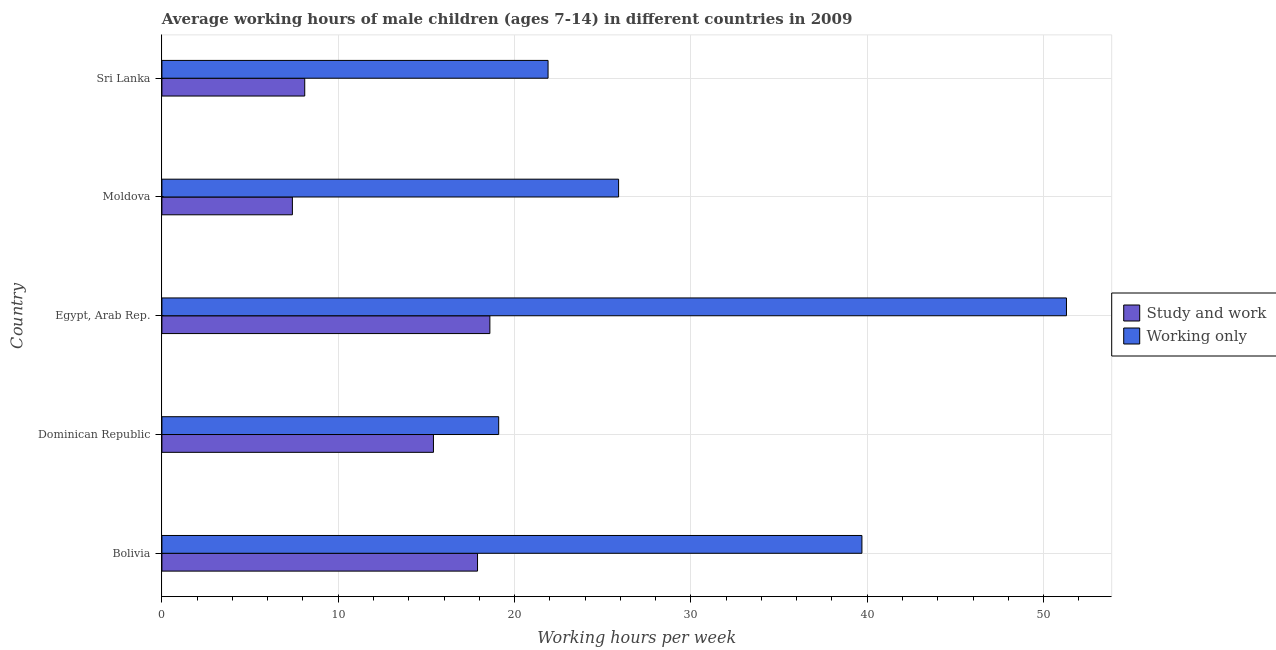How many different coloured bars are there?
Offer a terse response. 2. How many groups of bars are there?
Make the answer very short. 5. Are the number of bars per tick equal to the number of legend labels?
Ensure brevity in your answer.  Yes. Are the number of bars on each tick of the Y-axis equal?
Provide a short and direct response. Yes. How many bars are there on the 5th tick from the bottom?
Offer a very short reply. 2. What is the label of the 2nd group of bars from the top?
Your response must be concise. Moldova. In how many cases, is the number of bars for a given country not equal to the number of legend labels?
Ensure brevity in your answer.  0. What is the average working hour of children involved in only work in Sri Lanka?
Your answer should be very brief. 21.9. Across all countries, what is the maximum average working hour of children involved in only work?
Offer a very short reply. 51.3. In which country was the average working hour of children involved in only work maximum?
Give a very brief answer. Egypt, Arab Rep. In which country was the average working hour of children involved in only work minimum?
Provide a succinct answer. Dominican Republic. What is the total average working hour of children involved in study and work in the graph?
Ensure brevity in your answer.  67.4. What is the difference between the average working hour of children involved in only work in Dominican Republic and the average working hour of children involved in study and work in Bolivia?
Offer a terse response. 1.2. What is the average average working hour of children involved in study and work per country?
Keep it short and to the point. 13.48. What is the ratio of the average working hour of children involved in study and work in Bolivia to that in Moldova?
Give a very brief answer. 2.42. Is the difference between the average working hour of children involved in study and work in Egypt, Arab Rep. and Moldova greater than the difference between the average working hour of children involved in only work in Egypt, Arab Rep. and Moldova?
Your answer should be compact. No. What is the difference between the highest and the second highest average working hour of children involved in study and work?
Keep it short and to the point. 0.7. What is the difference between the highest and the lowest average working hour of children involved in only work?
Your answer should be compact. 32.2. In how many countries, is the average working hour of children involved in study and work greater than the average average working hour of children involved in study and work taken over all countries?
Your response must be concise. 3. What does the 1st bar from the top in Dominican Republic represents?
Provide a succinct answer. Working only. What does the 2nd bar from the bottom in Moldova represents?
Offer a terse response. Working only. Are all the bars in the graph horizontal?
Provide a short and direct response. Yes. What is the difference between two consecutive major ticks on the X-axis?
Your answer should be compact. 10. Does the graph contain any zero values?
Keep it short and to the point. No. What is the title of the graph?
Keep it short and to the point. Average working hours of male children (ages 7-14) in different countries in 2009. What is the label or title of the X-axis?
Offer a terse response. Working hours per week. What is the label or title of the Y-axis?
Provide a short and direct response. Country. What is the Working hours per week in Working only in Bolivia?
Your answer should be very brief. 39.7. What is the Working hours per week in Study and work in Dominican Republic?
Your response must be concise. 15.4. What is the Working hours per week of Working only in Dominican Republic?
Your response must be concise. 19.1. What is the Working hours per week of Study and work in Egypt, Arab Rep.?
Offer a terse response. 18.6. What is the Working hours per week in Working only in Egypt, Arab Rep.?
Make the answer very short. 51.3. What is the Working hours per week in Working only in Moldova?
Offer a terse response. 25.9. What is the Working hours per week of Working only in Sri Lanka?
Provide a succinct answer. 21.9. Across all countries, what is the maximum Working hours per week of Working only?
Ensure brevity in your answer.  51.3. What is the total Working hours per week of Study and work in the graph?
Your answer should be very brief. 67.4. What is the total Working hours per week of Working only in the graph?
Provide a short and direct response. 157.9. What is the difference between the Working hours per week of Working only in Bolivia and that in Dominican Republic?
Your answer should be very brief. 20.6. What is the difference between the Working hours per week of Study and work in Bolivia and that in Moldova?
Make the answer very short. 10.5. What is the difference between the Working hours per week of Working only in Bolivia and that in Sri Lanka?
Keep it short and to the point. 17.8. What is the difference between the Working hours per week of Working only in Dominican Republic and that in Egypt, Arab Rep.?
Your answer should be compact. -32.2. What is the difference between the Working hours per week in Study and work in Dominican Republic and that in Moldova?
Give a very brief answer. 8. What is the difference between the Working hours per week in Working only in Dominican Republic and that in Moldova?
Your answer should be compact. -6.8. What is the difference between the Working hours per week in Study and work in Egypt, Arab Rep. and that in Moldova?
Your answer should be compact. 11.2. What is the difference between the Working hours per week of Working only in Egypt, Arab Rep. and that in Moldova?
Make the answer very short. 25.4. What is the difference between the Working hours per week of Working only in Egypt, Arab Rep. and that in Sri Lanka?
Your response must be concise. 29.4. What is the difference between the Working hours per week in Study and work in Moldova and that in Sri Lanka?
Your answer should be very brief. -0.7. What is the difference between the Working hours per week in Working only in Moldova and that in Sri Lanka?
Offer a very short reply. 4. What is the difference between the Working hours per week in Study and work in Bolivia and the Working hours per week in Working only in Dominican Republic?
Provide a succinct answer. -1.2. What is the difference between the Working hours per week in Study and work in Bolivia and the Working hours per week in Working only in Egypt, Arab Rep.?
Provide a short and direct response. -33.4. What is the difference between the Working hours per week of Study and work in Dominican Republic and the Working hours per week of Working only in Egypt, Arab Rep.?
Offer a very short reply. -35.9. What is the difference between the Working hours per week of Study and work in Dominican Republic and the Working hours per week of Working only in Sri Lanka?
Your answer should be very brief. -6.5. What is the difference between the Working hours per week in Study and work in Egypt, Arab Rep. and the Working hours per week in Working only in Moldova?
Offer a very short reply. -7.3. What is the average Working hours per week of Study and work per country?
Offer a terse response. 13.48. What is the average Working hours per week in Working only per country?
Ensure brevity in your answer.  31.58. What is the difference between the Working hours per week in Study and work and Working hours per week in Working only in Bolivia?
Offer a very short reply. -21.8. What is the difference between the Working hours per week in Study and work and Working hours per week in Working only in Dominican Republic?
Provide a succinct answer. -3.7. What is the difference between the Working hours per week in Study and work and Working hours per week in Working only in Egypt, Arab Rep.?
Offer a terse response. -32.7. What is the difference between the Working hours per week of Study and work and Working hours per week of Working only in Moldova?
Provide a short and direct response. -18.5. What is the difference between the Working hours per week of Study and work and Working hours per week of Working only in Sri Lanka?
Offer a very short reply. -13.8. What is the ratio of the Working hours per week of Study and work in Bolivia to that in Dominican Republic?
Your response must be concise. 1.16. What is the ratio of the Working hours per week in Working only in Bolivia to that in Dominican Republic?
Your answer should be compact. 2.08. What is the ratio of the Working hours per week in Study and work in Bolivia to that in Egypt, Arab Rep.?
Keep it short and to the point. 0.96. What is the ratio of the Working hours per week of Working only in Bolivia to that in Egypt, Arab Rep.?
Ensure brevity in your answer.  0.77. What is the ratio of the Working hours per week in Study and work in Bolivia to that in Moldova?
Keep it short and to the point. 2.42. What is the ratio of the Working hours per week in Working only in Bolivia to that in Moldova?
Provide a succinct answer. 1.53. What is the ratio of the Working hours per week of Study and work in Bolivia to that in Sri Lanka?
Keep it short and to the point. 2.21. What is the ratio of the Working hours per week of Working only in Bolivia to that in Sri Lanka?
Offer a terse response. 1.81. What is the ratio of the Working hours per week in Study and work in Dominican Republic to that in Egypt, Arab Rep.?
Your answer should be compact. 0.83. What is the ratio of the Working hours per week of Working only in Dominican Republic to that in Egypt, Arab Rep.?
Offer a very short reply. 0.37. What is the ratio of the Working hours per week of Study and work in Dominican Republic to that in Moldova?
Ensure brevity in your answer.  2.08. What is the ratio of the Working hours per week in Working only in Dominican Republic to that in Moldova?
Your answer should be compact. 0.74. What is the ratio of the Working hours per week in Study and work in Dominican Republic to that in Sri Lanka?
Offer a terse response. 1.9. What is the ratio of the Working hours per week in Working only in Dominican Republic to that in Sri Lanka?
Keep it short and to the point. 0.87. What is the ratio of the Working hours per week of Study and work in Egypt, Arab Rep. to that in Moldova?
Keep it short and to the point. 2.51. What is the ratio of the Working hours per week of Working only in Egypt, Arab Rep. to that in Moldova?
Make the answer very short. 1.98. What is the ratio of the Working hours per week of Study and work in Egypt, Arab Rep. to that in Sri Lanka?
Offer a very short reply. 2.3. What is the ratio of the Working hours per week of Working only in Egypt, Arab Rep. to that in Sri Lanka?
Make the answer very short. 2.34. What is the ratio of the Working hours per week in Study and work in Moldova to that in Sri Lanka?
Give a very brief answer. 0.91. What is the ratio of the Working hours per week of Working only in Moldova to that in Sri Lanka?
Your answer should be compact. 1.18. What is the difference between the highest and the second highest Working hours per week of Study and work?
Provide a succinct answer. 0.7. What is the difference between the highest and the second highest Working hours per week of Working only?
Ensure brevity in your answer.  11.6. What is the difference between the highest and the lowest Working hours per week in Study and work?
Provide a short and direct response. 11.2. What is the difference between the highest and the lowest Working hours per week of Working only?
Keep it short and to the point. 32.2. 